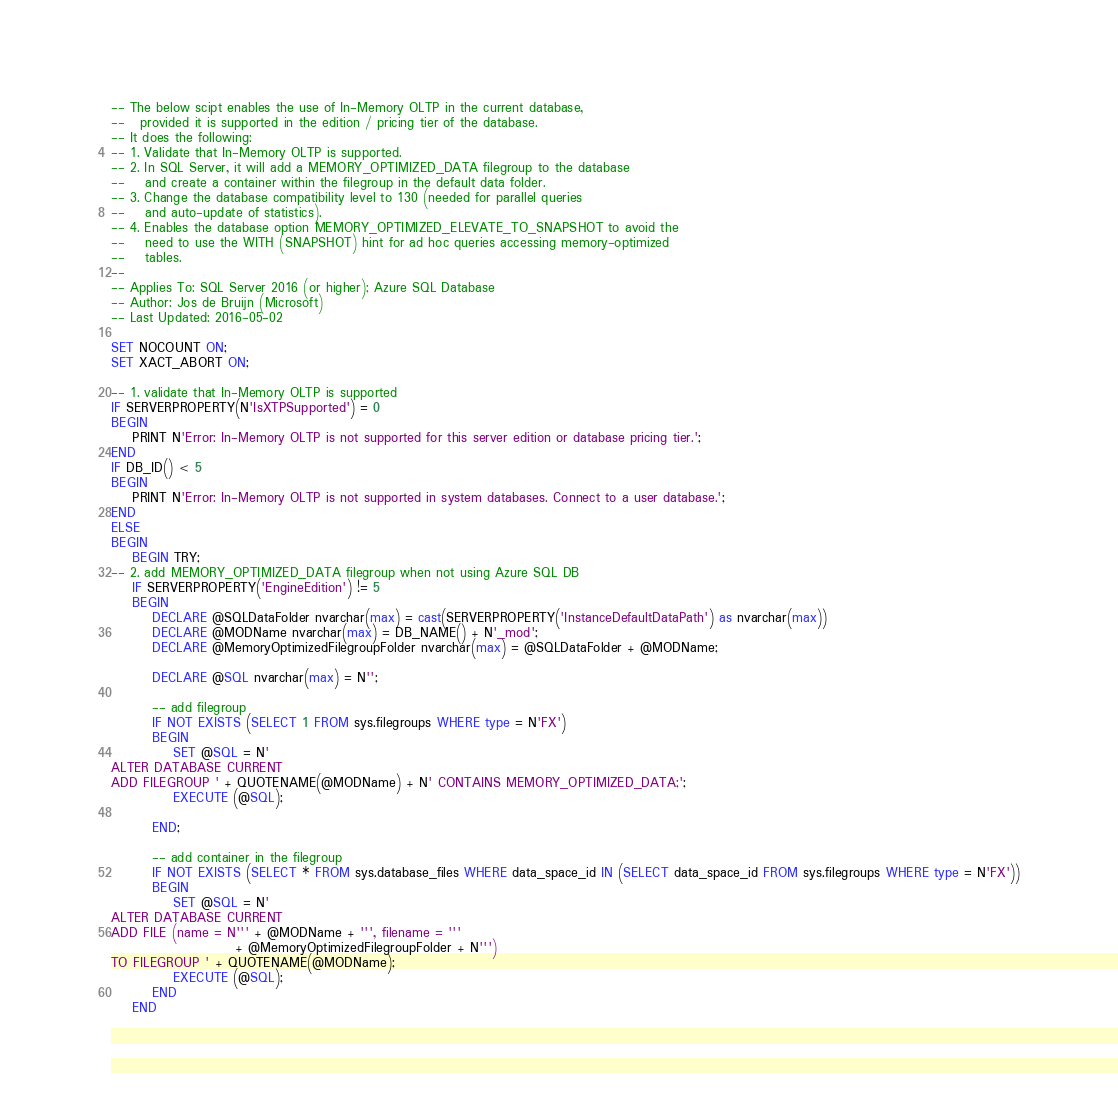Convert code to text. <code><loc_0><loc_0><loc_500><loc_500><_SQL_>-- The below scipt enables the use of In-Memory OLTP in the current database, 
--   provided it is supported in the edition / pricing tier of the database.
-- It does the following:
-- 1. Validate that In-Memory OLTP is supported. 
-- 2. In SQL Server, it will add a MEMORY_OPTIMIZED_DATA filegroup to the database
--    and create a container within the filegroup in the default data folder.
-- 3. Change the database compatibility level to 130 (needed for parallel queries
--    and auto-update of statistics).
-- 4. Enables the database option MEMORY_OPTIMIZED_ELEVATE_TO_SNAPSHOT to avoid the 
--    need to use the WITH (SNAPSHOT) hint for ad hoc queries accessing memory-optimized
--    tables.
--
-- Applies To: SQL Server 2016 (or higher); Azure SQL Database
-- Author: Jos de Bruijn (Microsoft)
-- Last Updated: 2016-05-02

SET NOCOUNT ON;
SET XACT_ABORT ON;

-- 1. validate that In-Memory OLTP is supported
IF SERVERPROPERTY(N'IsXTPSupported') = 0 
BEGIN                                    
    PRINT N'Error: In-Memory OLTP is not supported for this server edition or database pricing tier.';
END 
IF DB_ID() < 5
BEGIN                                    
    PRINT N'Error: In-Memory OLTP is not supported in system databases. Connect to a user database.';
END 
ELSE 
BEGIN 
	BEGIN TRY;
-- 2. add MEMORY_OPTIMIZED_DATA filegroup when not using Azure SQL DB
	IF SERVERPROPERTY('EngineEdition') != 5 
	BEGIN
		DECLARE @SQLDataFolder nvarchar(max) = cast(SERVERPROPERTY('InstanceDefaultDataPath') as nvarchar(max))
		DECLARE @MODName nvarchar(max) = DB_NAME() + N'_mod';
		DECLARE @MemoryOptimizedFilegroupFolder nvarchar(max) = @SQLDataFolder + @MODName;

		DECLARE @SQL nvarchar(max) = N'';

		-- add filegroup
		IF NOT EXISTS (SELECT 1 FROM sys.filegroups WHERE type = N'FX')
		BEGIN
			SET @SQL = N'
ALTER DATABASE CURRENT 
ADD FILEGROUP ' + QUOTENAME(@MODName) + N' CONTAINS MEMORY_OPTIMIZED_DATA;';
			EXECUTE (@SQL);

		END;

		-- add container in the filegroup
		IF NOT EXISTS (SELECT * FROM sys.database_files WHERE data_space_id IN (SELECT data_space_id FROM sys.filegroups WHERE type = N'FX'))
		BEGIN
			SET @SQL = N'
ALTER DATABASE CURRENT
ADD FILE (name = N''' + @MODName + ''', filename = '''
						+ @MemoryOptimizedFilegroupFolder + N''') 
TO FILEGROUP ' + QUOTENAME(@MODName);
			EXECUTE (@SQL);
		END
	END
</code> 